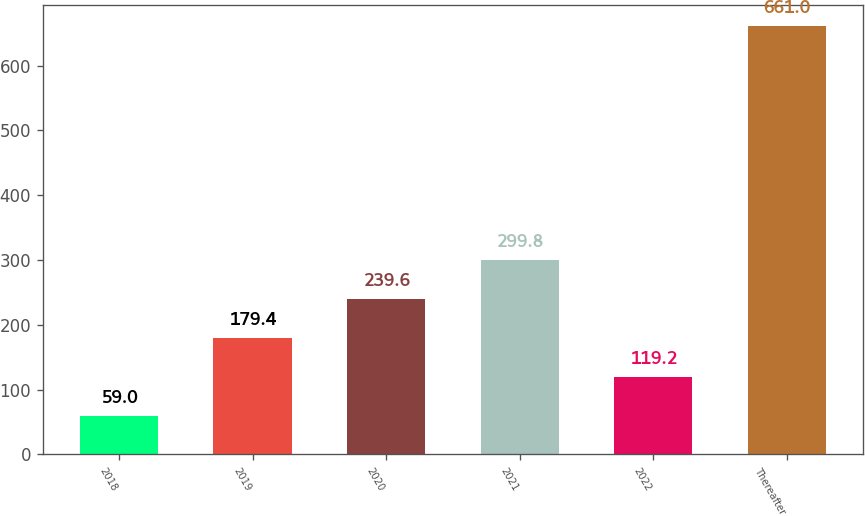Convert chart. <chart><loc_0><loc_0><loc_500><loc_500><bar_chart><fcel>2018<fcel>2019<fcel>2020<fcel>2021<fcel>2022<fcel>Thereafter<nl><fcel>59<fcel>179.4<fcel>239.6<fcel>299.8<fcel>119.2<fcel>661<nl></chart> 